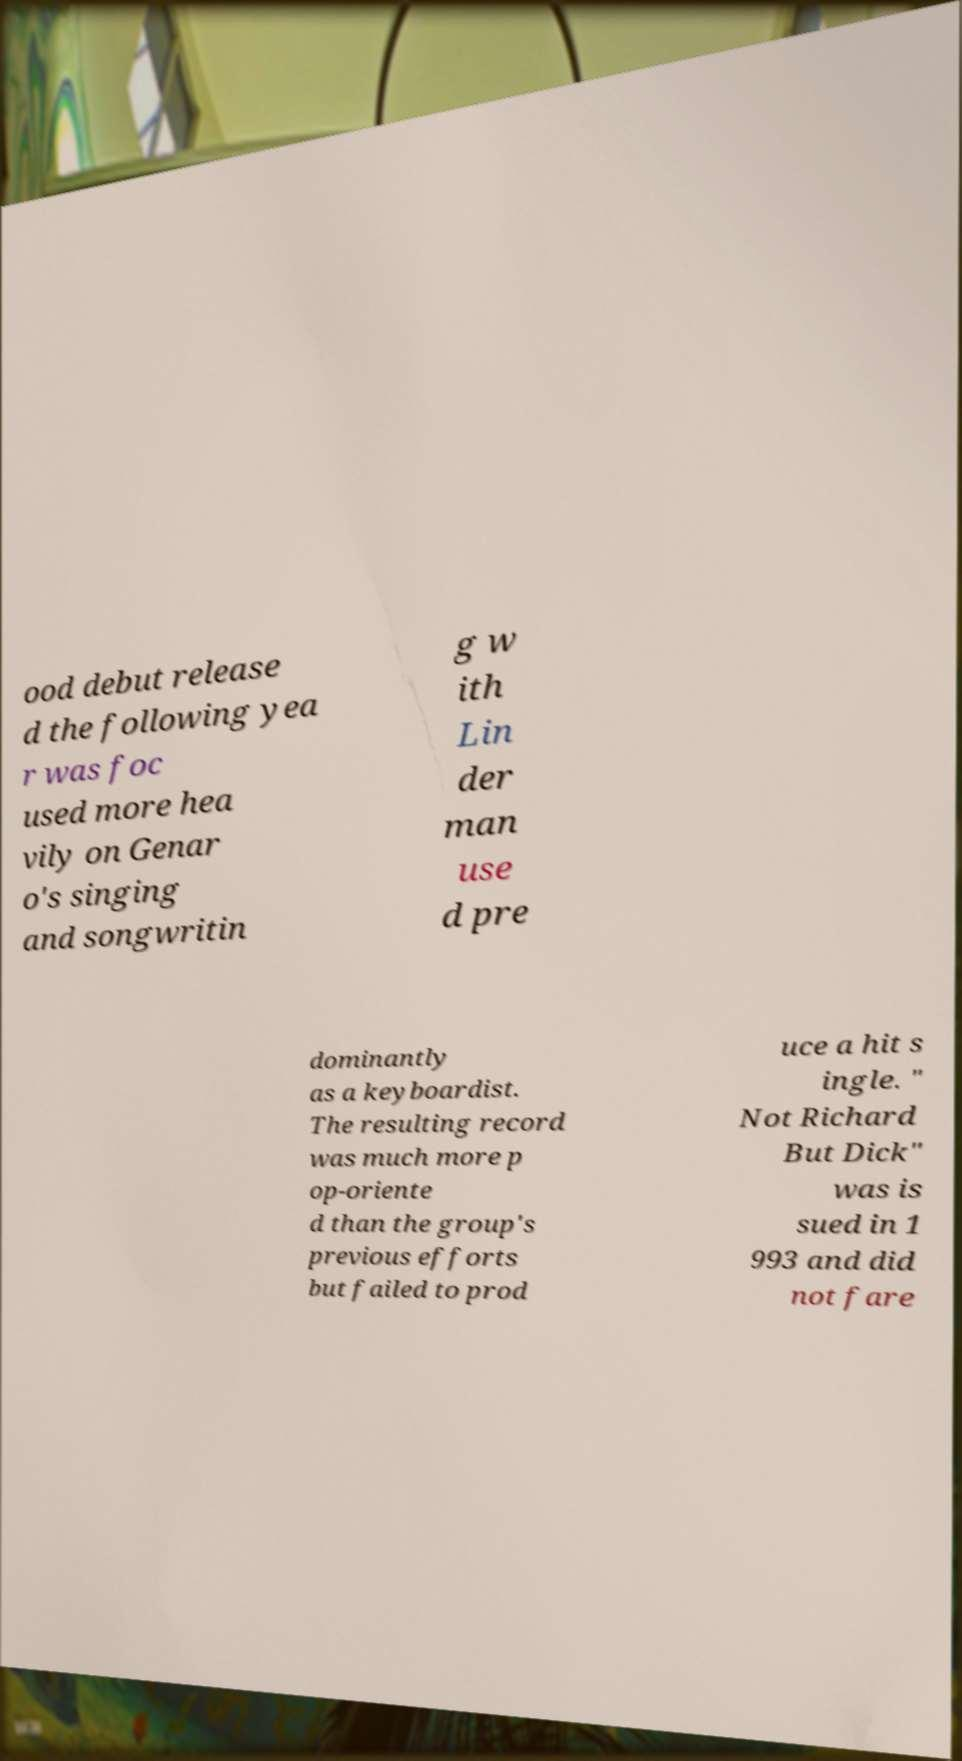Please read and relay the text visible in this image. What does it say? ood debut release d the following yea r was foc used more hea vily on Genar o's singing and songwritin g w ith Lin der man use d pre dominantly as a keyboardist. The resulting record was much more p op-oriente d than the group's previous efforts but failed to prod uce a hit s ingle. " Not Richard But Dick" was is sued in 1 993 and did not fare 